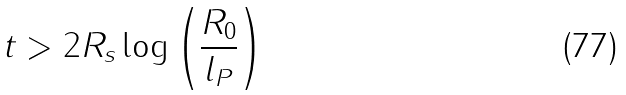<formula> <loc_0><loc_0><loc_500><loc_500>t > 2 R _ { s } \log \left ( \frac { R _ { 0 } } { l _ { P } } \right )</formula> 